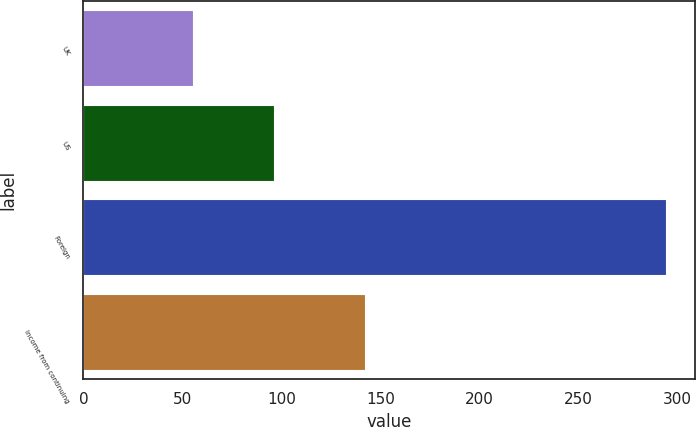Convert chart to OTSL. <chart><loc_0><loc_0><loc_500><loc_500><bar_chart><fcel>UK<fcel>US<fcel>Foreign<fcel>Income from continuing<nl><fcel>55.4<fcel>96.4<fcel>294.1<fcel>142.3<nl></chart> 